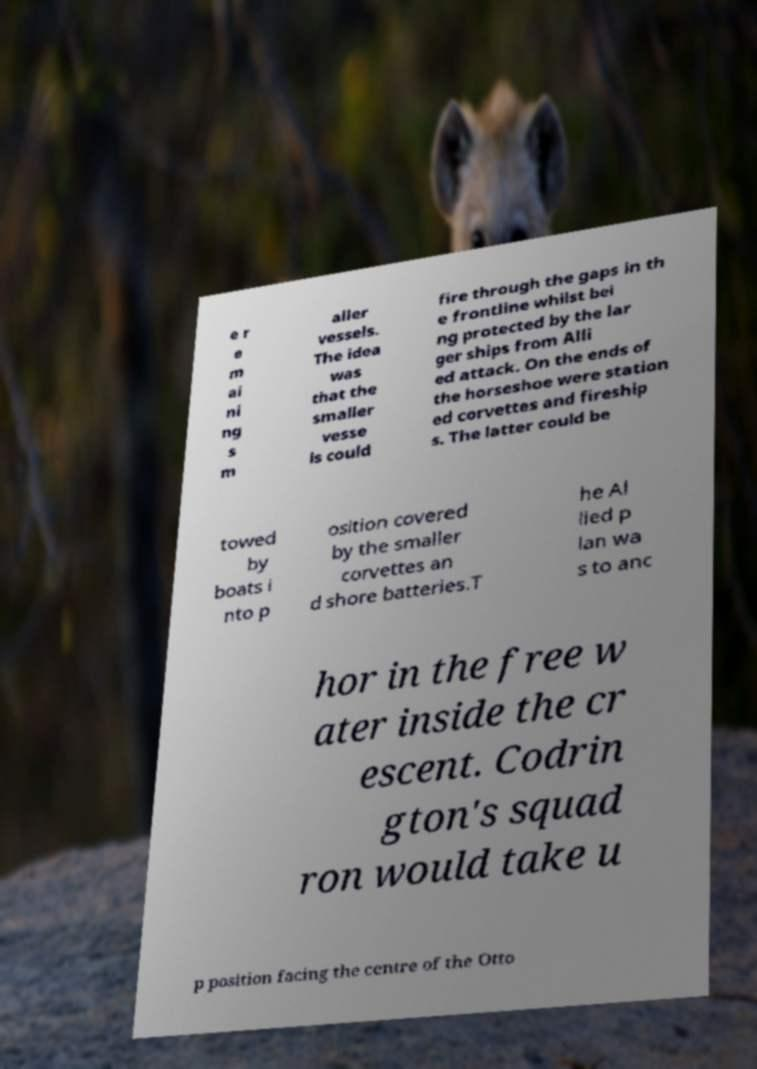Please read and relay the text visible in this image. What does it say? e r e m ai ni ng s m aller vessels. The idea was that the smaller vesse ls could fire through the gaps in th e frontline whilst bei ng protected by the lar ger ships from Alli ed attack. On the ends of the horseshoe were station ed corvettes and fireship s. The latter could be towed by boats i nto p osition covered by the smaller corvettes an d shore batteries.T he Al lied p lan wa s to anc hor in the free w ater inside the cr escent. Codrin gton's squad ron would take u p position facing the centre of the Otto 